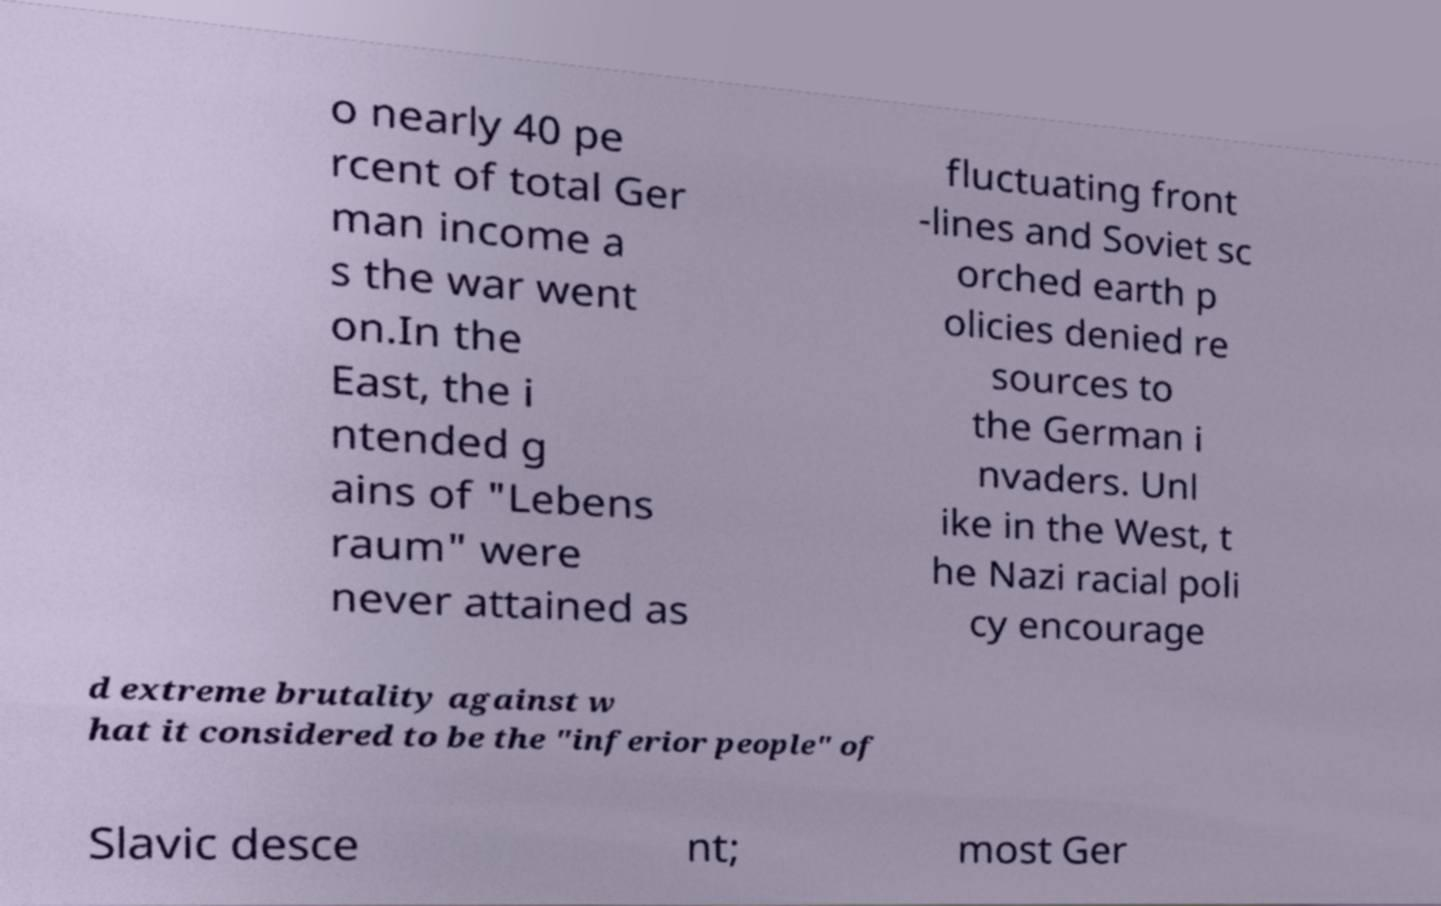I need the written content from this picture converted into text. Can you do that? o nearly 40 pe rcent of total Ger man income a s the war went on.In the East, the i ntended g ains of "Lebens raum" were never attained as fluctuating front -lines and Soviet sc orched earth p olicies denied re sources to the German i nvaders. Unl ike in the West, t he Nazi racial poli cy encourage d extreme brutality against w hat it considered to be the "inferior people" of Slavic desce nt; most Ger 